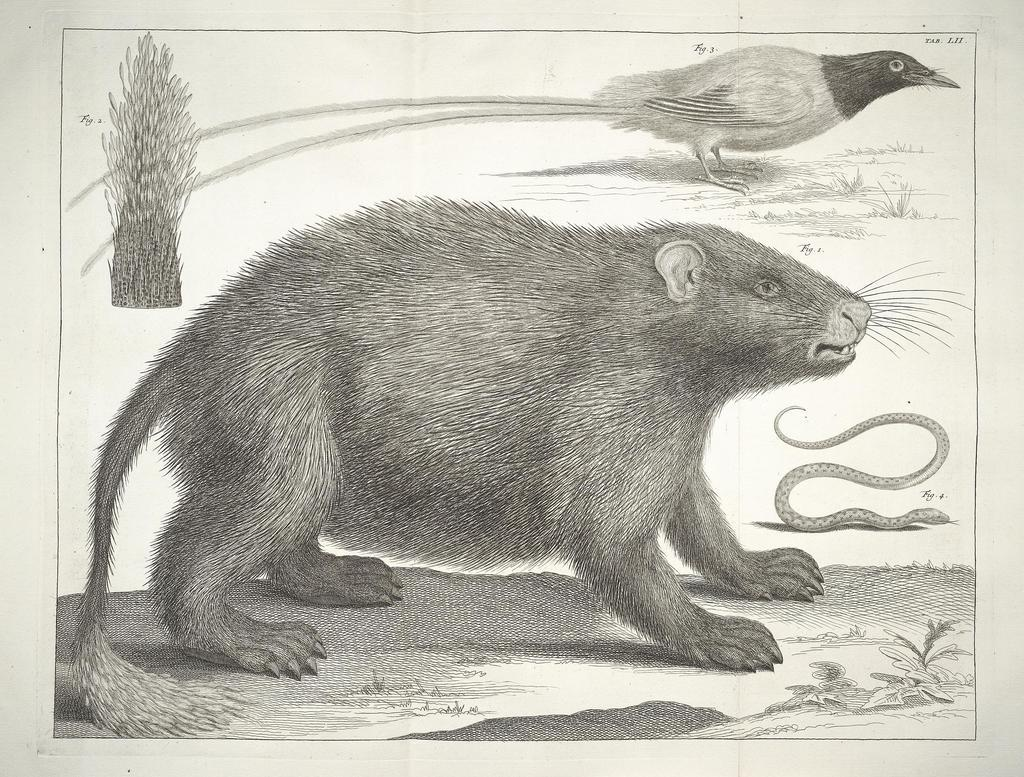What types of animals can be seen in the image? There are different animal species in the image. Where are the animals located in the image? The animal species are in the center of the image. How many sisters are present at the edge of the image? There are no sisters mentioned in the image, and the edge of the image is not described. 